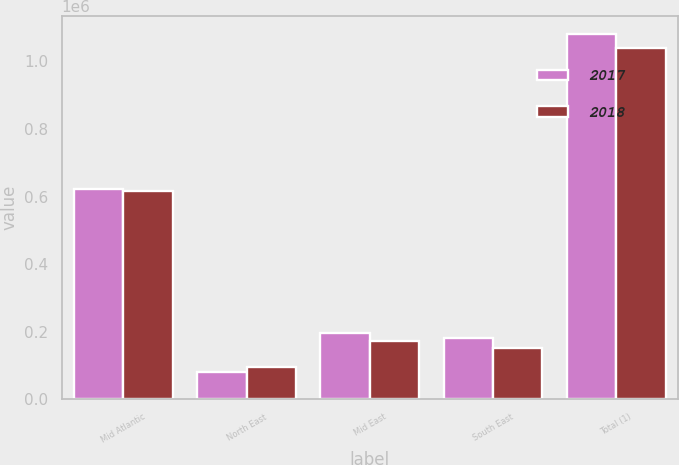Convert chart. <chart><loc_0><loc_0><loc_500><loc_500><stacked_bar_chart><ecel><fcel>Mid Atlantic<fcel>North East<fcel>Mid East<fcel>South East<fcel>Total (1)<nl><fcel>2017<fcel>622997<fcel>79530<fcel>195149<fcel>182458<fcel>1.08013e+06<nl><fcel>2018<fcel>617471<fcel>96412<fcel>173572<fcel>151219<fcel>1.03867e+06<nl></chart> 